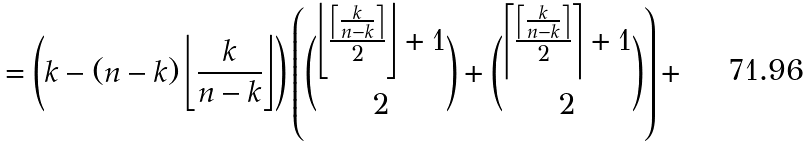Convert formula to latex. <formula><loc_0><loc_0><loc_500><loc_500>= \left ( k - ( n - k ) \left \lfloor \frac { k } { n - k } \right \rfloor \right ) \left ( \binom { \left \lfloor \frac { \left \lceil \frac { k } { n - k } \right \rceil } { 2 } \right \rfloor + 1 } { 2 } + \binom { \left \lceil \frac { \left \lceil \frac { k } { n - k } \right \rceil } { 2 } \right \rceil + 1 } { 2 } \right ) +</formula> 